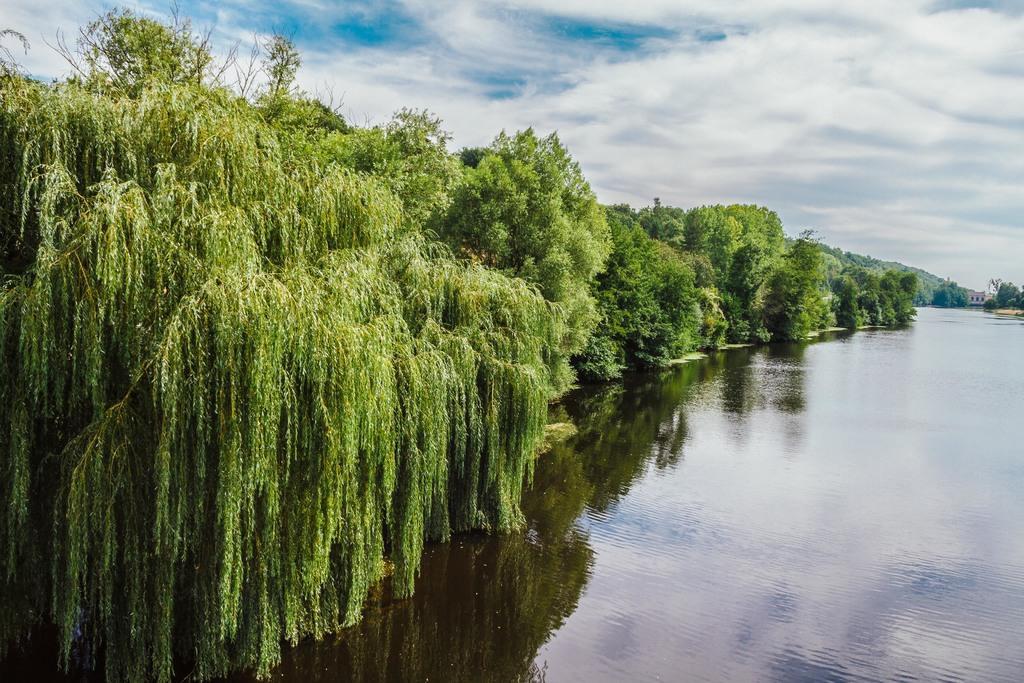Can you describe this image briefly? In this image there are trees. At the bottom there is water. In the background there is sky. 